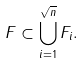Convert formula to latex. <formula><loc_0><loc_0><loc_500><loc_500>F \subset \bigcup _ { i = 1 } ^ { \sqrt { n } } F _ { i } .</formula> 